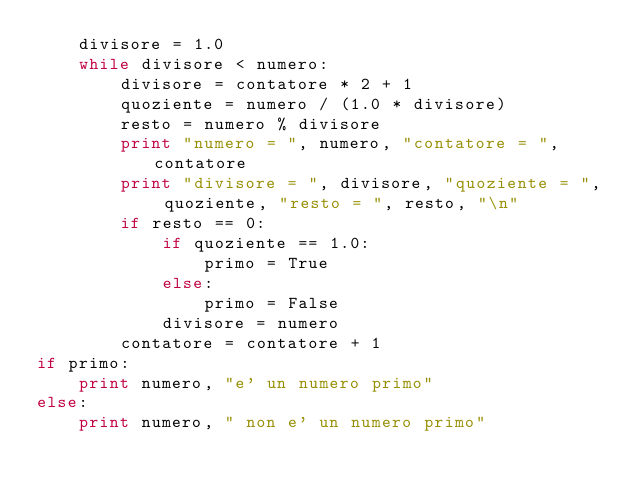Convert code to text. <code><loc_0><loc_0><loc_500><loc_500><_Python_>    divisore = 1.0
    while divisore < numero:
        divisore = contatore * 2 + 1
        quoziente = numero / (1.0 * divisore)
        resto = numero % divisore
        print "numero = ", numero, "contatore = ", contatore
        print "divisore = ", divisore, "quoziente = ", quoziente, "resto = ", resto, "\n"
        if resto == 0:
            if quoziente == 1.0:
                primo = True
            else:
                primo = False
            divisore = numero
        contatore = contatore + 1
if primo:
    print numero, "e' un numero primo"
else:
    print numero, " non e' un numero primo"
</code> 